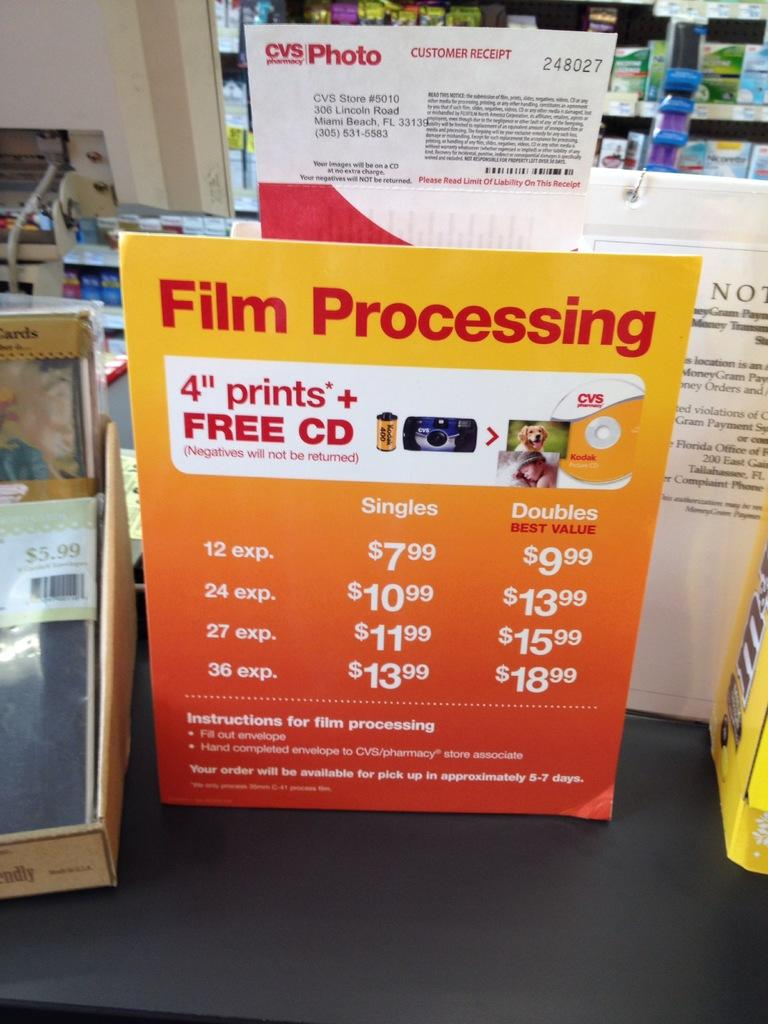Provide a one-sentence caption for the provided image. Cvs photo section in a store with a poster of the prices. 